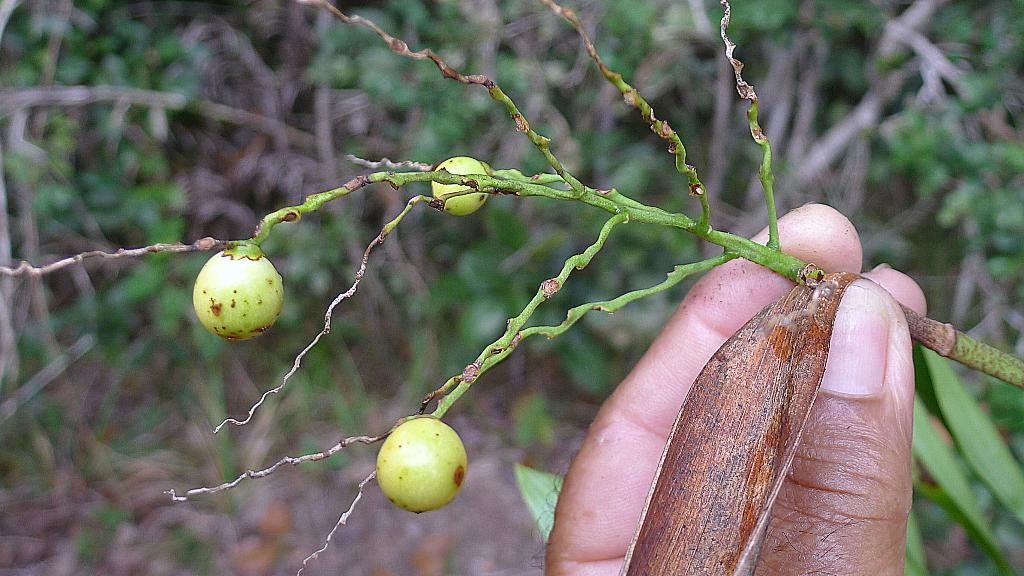What is the main subject of the image? There is a human in the image. What is the human doing in the image? The human is holding the stem of a plant. What type of yoke can be seen in the image? There is no yoke present in the image. What type of twig is the human holding in the image? The human is holding the stem of a plant, not a twig, in the image. Can you spot an owl in the image? There is no owl present in the image. 